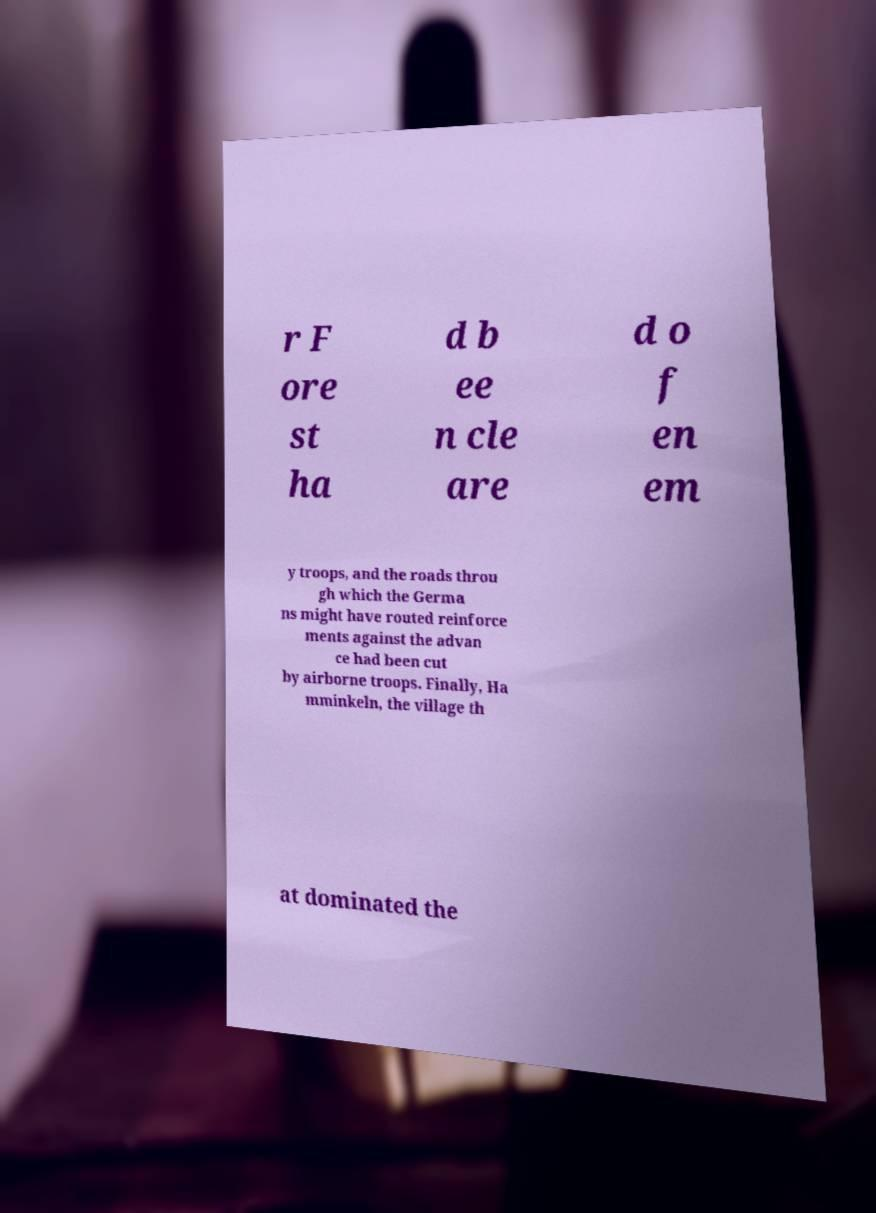Can you accurately transcribe the text from the provided image for me? r F ore st ha d b ee n cle are d o f en em y troops, and the roads throu gh which the Germa ns might have routed reinforce ments against the advan ce had been cut by airborne troops. Finally, Ha mminkeln, the village th at dominated the 